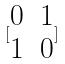Convert formula to latex. <formula><loc_0><loc_0><loc_500><loc_500>[ \begin{matrix} 0 & 1 \\ 1 & 0 \end{matrix} ]</formula> 